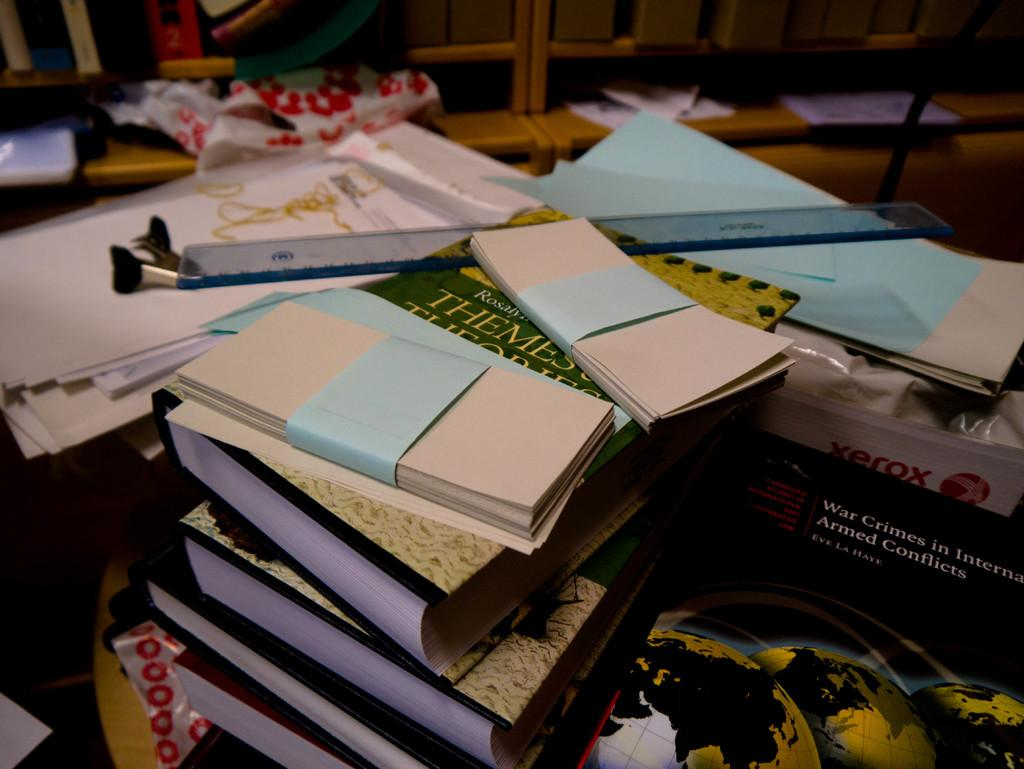<image>
Relay a brief, clear account of the picture shown. A desk is cluttered with books and one of them says Themes. 